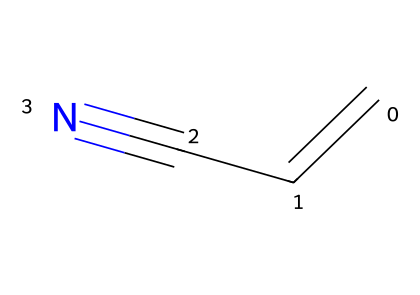What is the chemical name of the compound represented by the SMILES? The SMILES notation "C=CC#N" indicates the presence of a double bond between two carbon atoms and a nitrile functional group. This corresponds to the compound acrylonitrile.
Answer: acrylonitrile How many carbon atoms are present in acrylonitrile? By examining the SMILES notation, "C=CC#N", it shows that there are two carbon atoms in the alkene part (C=C) and one additional carbon in the nitrile (C#N), totaling three carbon atoms.
Answer: three What type of functional group is present in this chemical? The structure includes the "C#N" part, which signifies that acrylonitrile contains a nitrile functional group, characterized by the triple bond between carbon and nitrogen.
Answer: nitrile What is the total number of hydrogen atoms in acrylonitrile? The molecule "C=CC#N" can be counted for hydrogen atoms based on valence. Each carbon typically bonds with enough hydrogens to make four bonds total, leading to a count of three hydrogen atoms.
Answer: three How many π bonds are in the structure of acrylonitrile? In the notation "C=CC#N", the double bond (C=C) represents one π bond and the triple bond (C#N) accounts for two additional π bonds. Thus, the total number of π bonds is three.
Answer: three Is acrylonitrile structured with single, double, or triple bonds? Looking at the SMILES, "C=CC#N", the structural representation indicates both a double bond between the carbon atoms and a triple bond with the nitrogen atom. Hence, it features both double and triple bonds.
Answer: double and triple bonds What property likely allows acrylonitrile to be a precursor in synthetic rubber production? Acrylonitrile has a reactive C=C double bond, which enables it to undergo polymerization reactions, a key process in the creation of synthetic rubbers, facilitating the linking of many molecular units together.
Answer: reactivity 